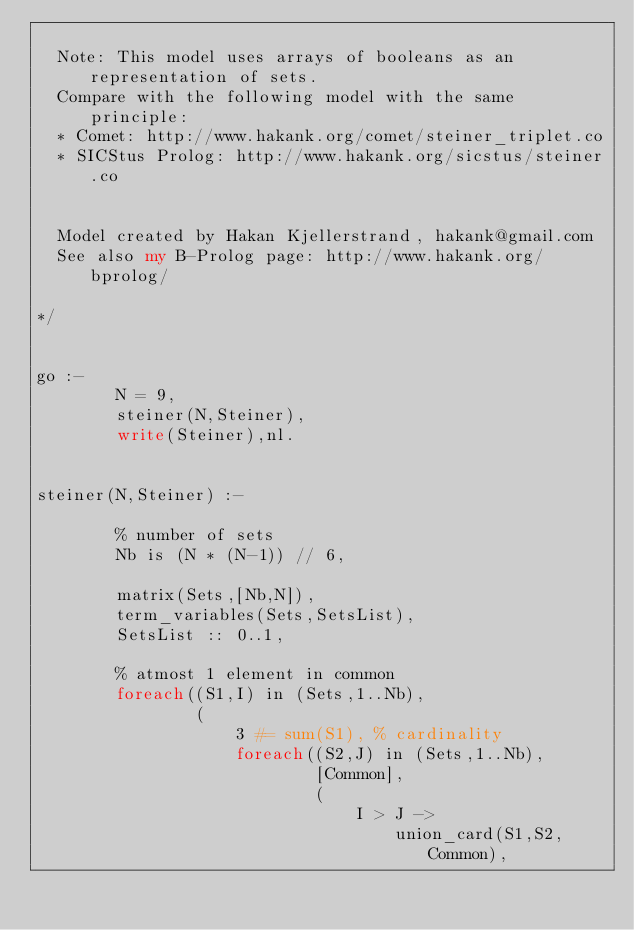<code> <loc_0><loc_0><loc_500><loc_500><_Perl_>
  Note: This model uses arrays of booleans as an representation of sets.
  Compare with the following model with the same principle:
  * Comet: http://www.hakank.org/comet/steiner_triplet.co
  * SICStus Prolog: http://www.hakank.org/sicstus/steiner.co


  Model created by Hakan Kjellerstrand, hakank@gmail.com
  See also my B-Prolog page: http://www.hakank.org/bprolog/

*/


go :-
        N = 9,
        steiner(N,Steiner),
        write(Steiner),nl.


steiner(N,Steiner) :-

        % number of sets
        Nb is (N * (N-1)) // 6,

        matrix(Sets,[Nb,N]),
        term_variables(Sets,SetsList),
        SetsList :: 0..1,

        % atmost 1 element in common
        foreach((S1,I) in (Sets,1..Nb),
                ( 
                    3 #= sum(S1), % cardinality
                    foreach((S2,J) in (Sets,1..Nb),
                            [Common],
                            (
                                I > J -> 
                                    union_card(S1,S2,Common),</code> 